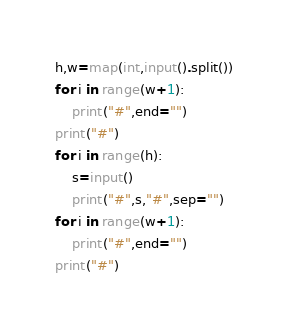<code> <loc_0><loc_0><loc_500><loc_500><_Python_>h,w=map(int,input().split())
for i in range(w+1):
    print("#",end="")
print("#")
for i in range(h):
    s=input()
    print("#",s,"#",sep="")
for i in range(w+1):
    print("#",end="")
print("#")</code> 